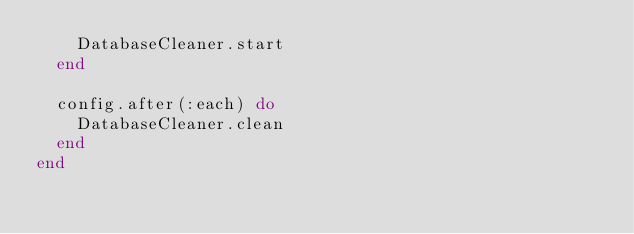<code> <loc_0><loc_0><loc_500><loc_500><_Ruby_>    DatabaseCleaner.start
  end

  config.after(:each) do
    DatabaseCleaner.clean
  end
end</code> 